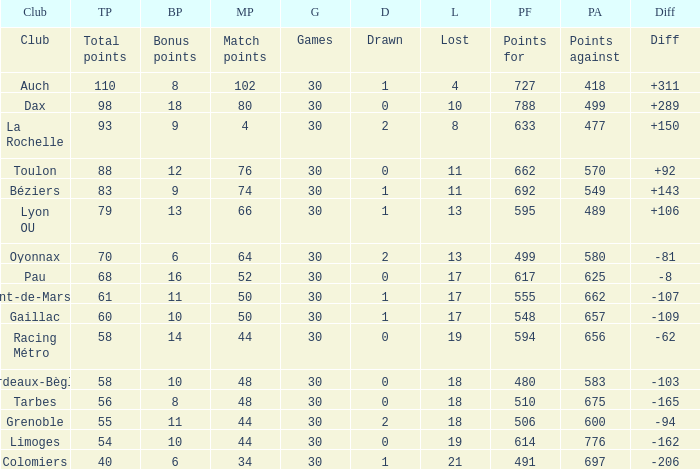How many bonus points did the Colomiers earn? 6.0. 